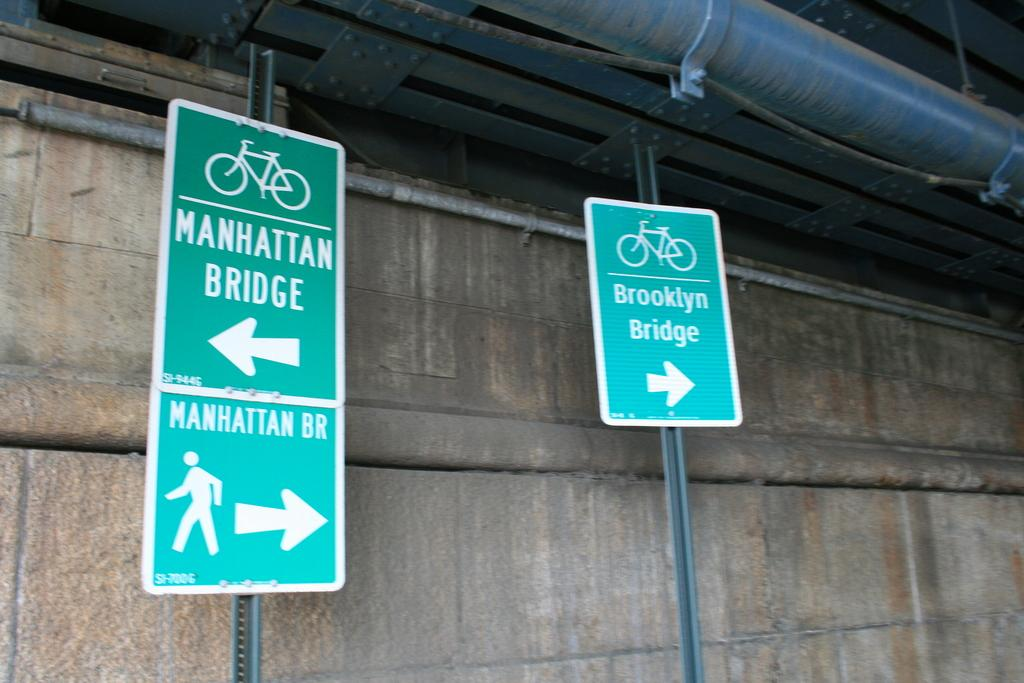<image>
Summarize the visual content of the image. Signs show the direction to the Brooklyn Bridge and the Manhattan Bridge. 